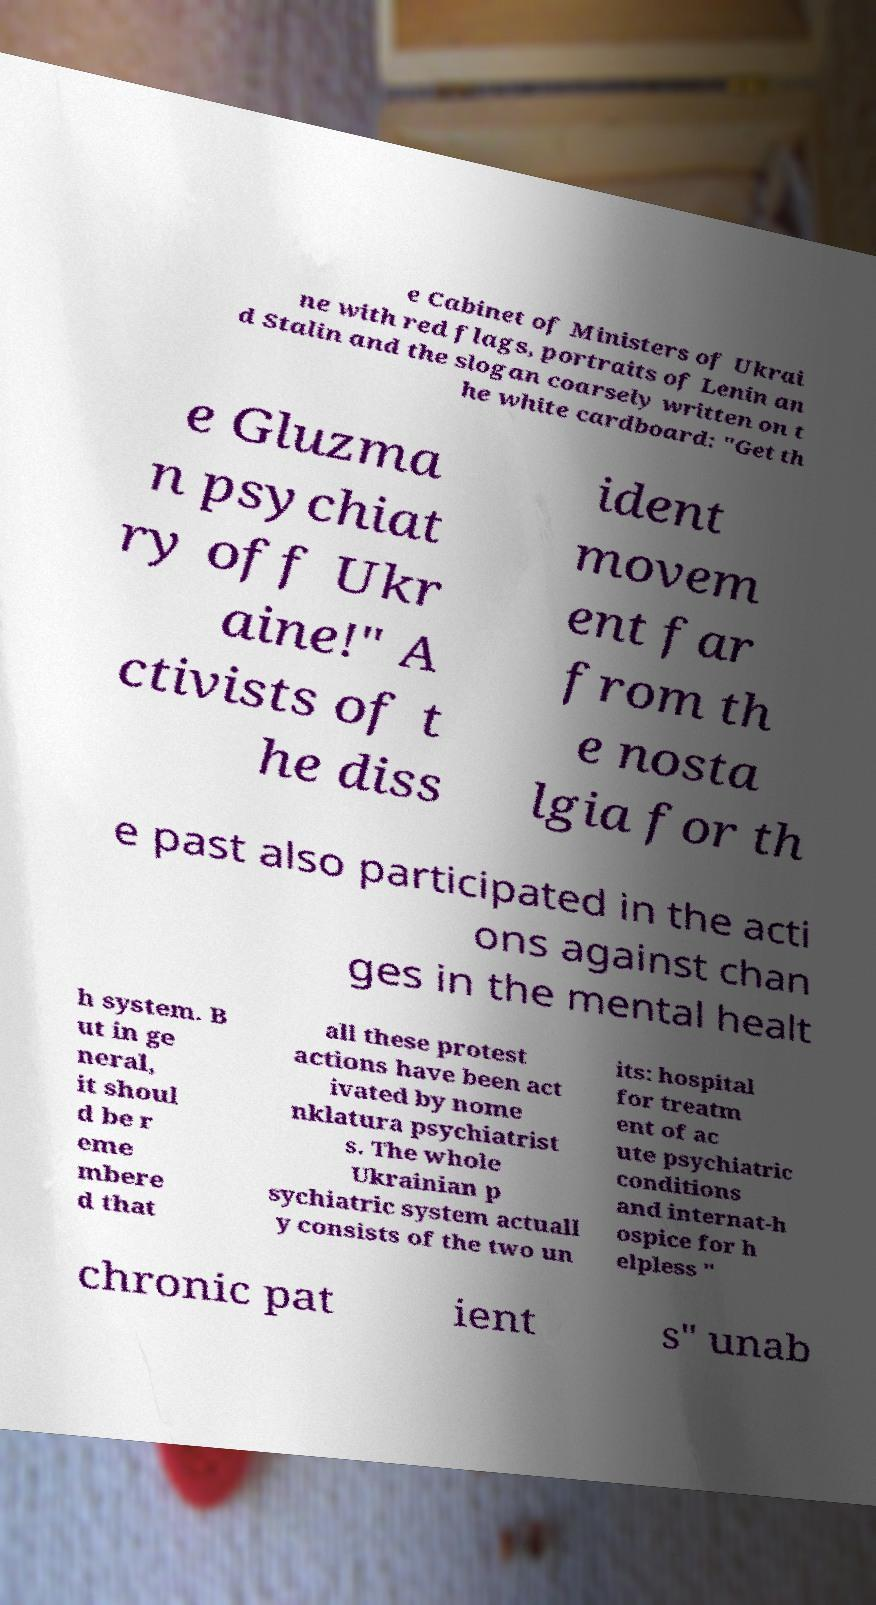Could you assist in decoding the text presented in this image and type it out clearly? e Cabinet of Ministers of Ukrai ne with red flags, portraits of Lenin an d Stalin and the slogan coarsely written on t he white cardboard: "Get th e Gluzma n psychiat ry off Ukr aine!" A ctivists of t he diss ident movem ent far from th e nosta lgia for th e past also participated in the acti ons against chan ges in the mental healt h system. B ut in ge neral, it shoul d be r eme mbere d that all these protest actions have been act ivated by nome nklatura psychiatrist s. The whole Ukrainian p sychiatric system actuall y consists of the two un its: hospital for treatm ent of ac ute psychiatric conditions and internat-h ospice for h elpless " chronic pat ient s" unab 